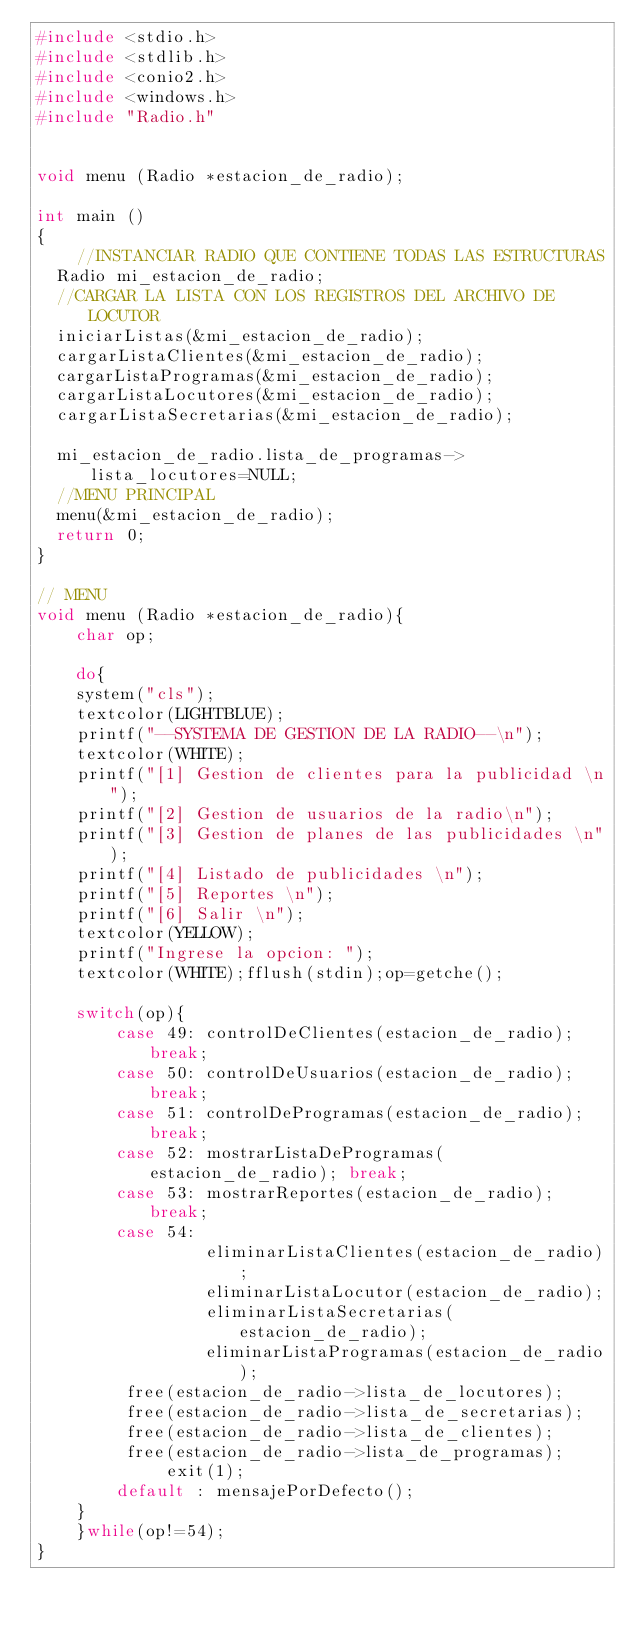<code> <loc_0><loc_0><loc_500><loc_500><_C_>#include <stdio.h>
#include <stdlib.h>
#include <conio2.h>
#include <windows.h>
#include "Radio.h"


void menu (Radio *estacion_de_radio);

int main ()
{
    //INSTANCIAR RADIO QUE CONTIENE TODAS LAS ESTRUCTURAS
	Radio mi_estacion_de_radio;
	//CARGAR LA LISTA CON LOS REGISTROS DEL ARCHIVO DE LOCUTOR
	iniciarListas(&mi_estacion_de_radio);
	cargarListaClientes(&mi_estacion_de_radio);
	cargarListaProgramas(&mi_estacion_de_radio);
	cargarListaLocutores(&mi_estacion_de_radio);
	cargarListaSecretarias(&mi_estacion_de_radio);

	mi_estacion_de_radio.lista_de_programas->lista_locutores=NULL;
	//MENU PRINCIPAL
	menu(&mi_estacion_de_radio);
	return 0;
}

// MENU
void menu (Radio *estacion_de_radio){
    char op;

    do{
    system("cls");
    textcolor(LIGHTBLUE);
    printf("--SYSTEMA DE GESTION DE LA RADIO--\n");
    textcolor(WHITE);
    printf("[1] Gestion de clientes para la publicidad \n");
    printf("[2] Gestion de usuarios de la radio\n");
    printf("[3] Gestion de planes de las publicidades \n");
    printf("[4] Listado de publicidades \n");
    printf("[5] Reportes \n");
    printf("[6] Salir \n");
    textcolor(YELLOW);
    printf("Ingrese la opcion: ");
    textcolor(WHITE);fflush(stdin);op=getche();

    switch(op){
        case 49: controlDeClientes(estacion_de_radio); break;
        case 50: controlDeUsuarios(estacion_de_radio); break;
        case 51: controlDeProgramas(estacion_de_radio); break;
        case 52: mostrarListaDeProgramas(estacion_de_radio); break;
        case 53: mostrarReportes(estacion_de_radio); break;
        case 54:
                 eliminarListaClientes(estacion_de_radio);
                 eliminarListaLocutor(estacion_de_radio);
                 eliminarListaSecretarias(estacion_de_radio);
                 eliminarListaProgramas(estacion_de_radio);
				 free(estacion_de_radio->lista_de_locutores);
				 free(estacion_de_radio->lista_de_secretarias);
				 free(estacion_de_radio->lista_de_clientes);
				 free(estacion_de_radio->lista_de_programas);
        		 exit(1);
        default : mensajePorDefecto();
    }
    }while(op!=54);
}

</code> 